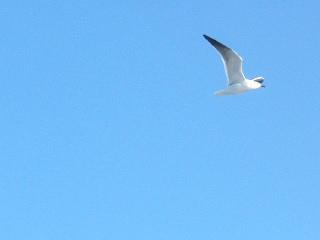Provide a brief description of the environment in which the main subject is located. The main subject, a sea gull, is flying in a clear blue sky on a sunny day with no clouds. Identify the type and color of the bird in the image. The bird is a sea gull with a white body, gray tips on its wings, a white tail, and a black beak. Using metaphorical language, describe the image of the bird. The lonely seagull soars like an ethereal white feather, gracefully embracing the boundless heavens as it glides through the celestial ocean of azure tranquility. How would you describe the bird's flying state? The bird is in a gliding motion with its wings spread wide open, smoothly making its way through the clear blue sky. Explain what the bird is doing and its position in the sky. The bird, a seagull, is flying with wings extended through the clear and sunny blue sky, with its tail and head held high. Provide a poetic description of the environment where the bird is flying. Amidst the vast expanse of azure skies, lies a solitary seagull, soaring gracefully on the wings of the gentle breeze, as it basks in the warm embrace of infinite sun rays. What is a captivating observation from the image? The captivating observation is the stark contrast between the sea gull's white body and dark beak against the backdrop of a cloudless blue sky. Identify three distinct features of the bird's appearance. Three distinct features of the bird's appearance are its white body, black-tipped wings, and black beak. Describe the body features and coloring of the bird. The sea gull has a white body, gray-tipped wings, a light gray tail, and a white head with a dark beak and tiny eye. What type of day is it, based on the details in the snapshots? Based on the image descriptions, it is a sunny day with a clear, blue, cloudless sky. 